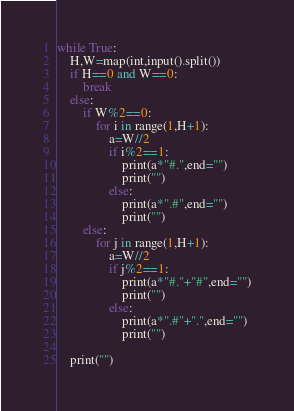<code> <loc_0><loc_0><loc_500><loc_500><_Python_>while True:
    H,W=map(int,input().split())
    if H==0 and W==0:
        break
    else:
        if W%2==0:
            for i in range(1,H+1):
                a=W//2
                if i%2==1:
                    print(a*"#.",end="")
                    print("")
                else:
                    print(a*".#",end="")
                    print("")
        else:
            for j in range(1,H+1):
                a=W//2
                if j%2==1:
                    print(a*"#."+"#",end="")
                    print("")
                else:
                    print(a*".#"+".",end="")
                    print("")
        
    print("")
</code> 